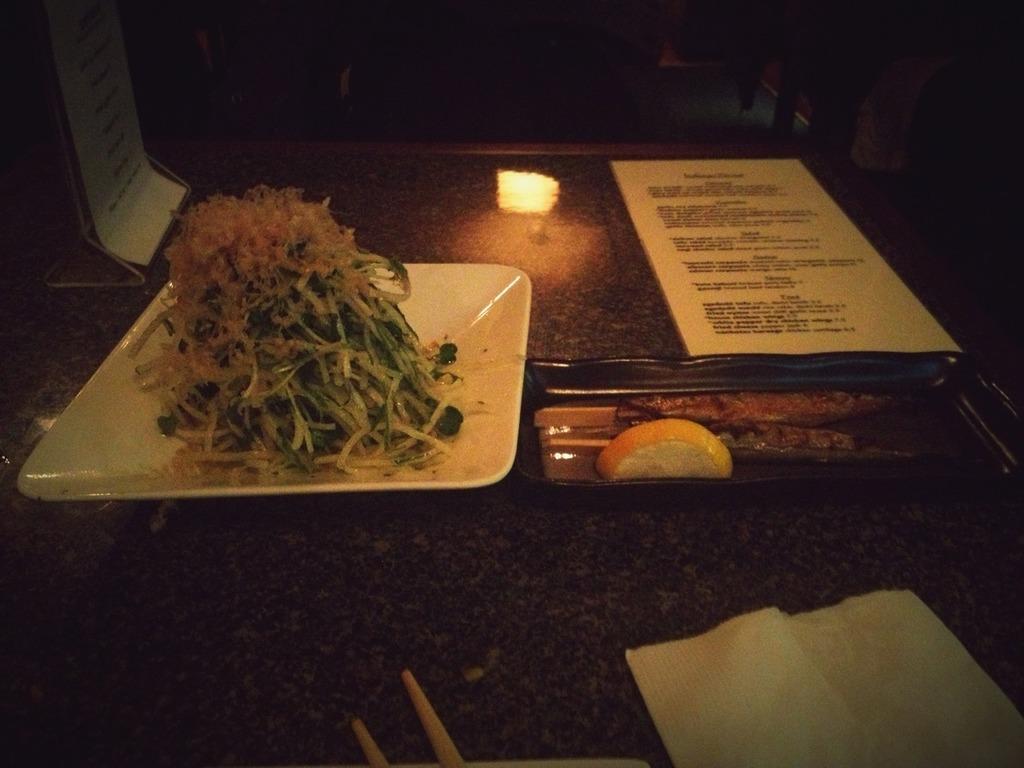How would you summarize this image in a sentence or two? In the image we can see there is a food item kept in the plate and there are chopsticks and tissue paper kept on the table. There is a meat dish and piece of lime kept on the plate. There is a menu card kept on the table. 